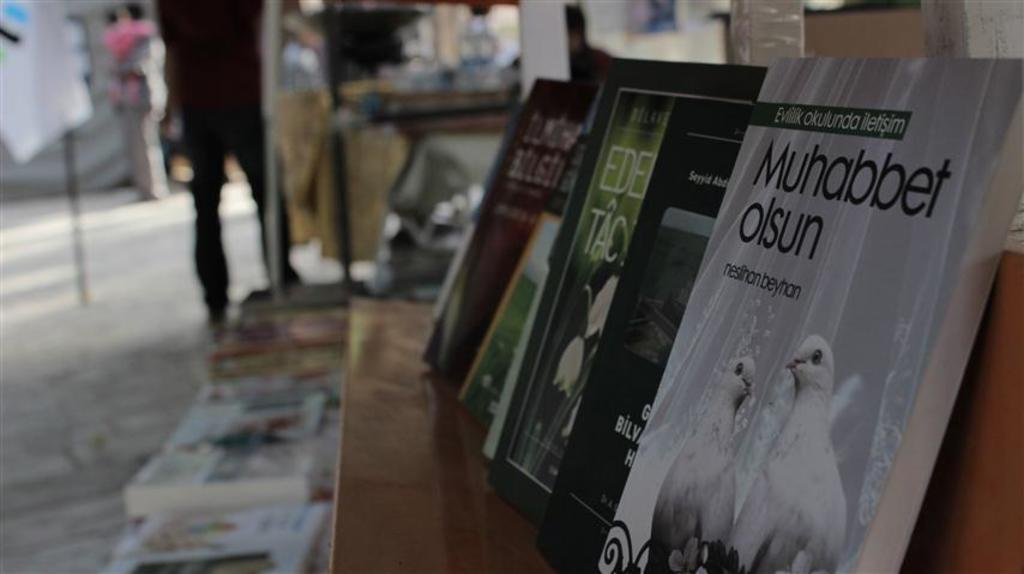<image>
Describe the image concisely. A row of books one of which says Muhabbet olsun 